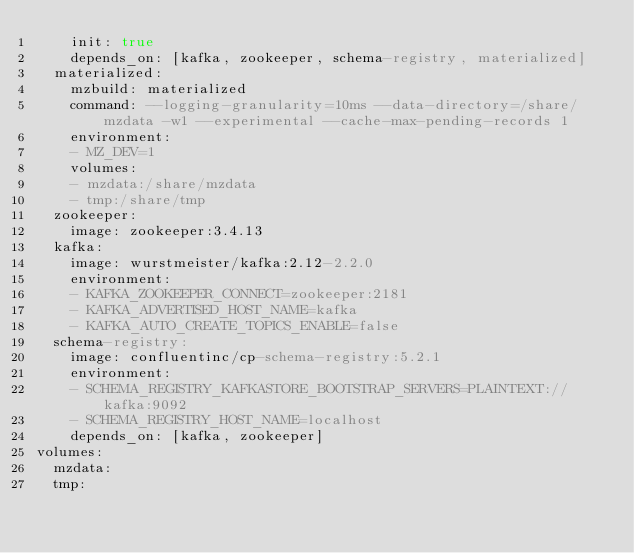<code> <loc_0><loc_0><loc_500><loc_500><_YAML_>    init: true
    depends_on: [kafka, zookeeper, schema-registry, materialized]
  materialized:
    mzbuild: materialized
    command: --logging-granularity=10ms --data-directory=/share/mzdata -w1 --experimental --cache-max-pending-records 1
    environment:
    - MZ_DEV=1
    volumes:
    - mzdata:/share/mzdata
    - tmp:/share/tmp
  zookeeper:
    image: zookeeper:3.4.13
  kafka:
    image: wurstmeister/kafka:2.12-2.2.0
    environment:
    - KAFKA_ZOOKEEPER_CONNECT=zookeeper:2181
    - KAFKA_ADVERTISED_HOST_NAME=kafka
    - KAFKA_AUTO_CREATE_TOPICS_ENABLE=false
  schema-registry:
    image: confluentinc/cp-schema-registry:5.2.1
    environment:
    - SCHEMA_REGISTRY_KAFKASTORE_BOOTSTRAP_SERVERS=PLAINTEXT://kafka:9092
    - SCHEMA_REGISTRY_HOST_NAME=localhost
    depends_on: [kafka, zookeeper]
volumes:
  mzdata:
  tmp:
</code> 